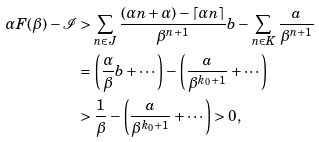<formula> <loc_0><loc_0><loc_500><loc_500>\alpha F ( \beta ) - \mathcal { I } & > \sum _ { n \in J } \frac { ( \alpha n + \alpha ) - \lceil \alpha n \rceil } { \beta ^ { n + 1 } } b - \sum _ { n \in K } \frac { a } { \beta ^ { n + 1 } } \\ & = \left ( \frac { \alpha } { \beta } b + \cdots \right ) - \left ( \frac { a } { \beta ^ { k _ { 0 } + 1 } } + \cdots \right ) \\ & > \frac { 1 } { \beta } - \left ( \frac { a } { \beta ^ { k _ { 0 } + 1 } } + \cdots \right ) > 0 ,</formula> 